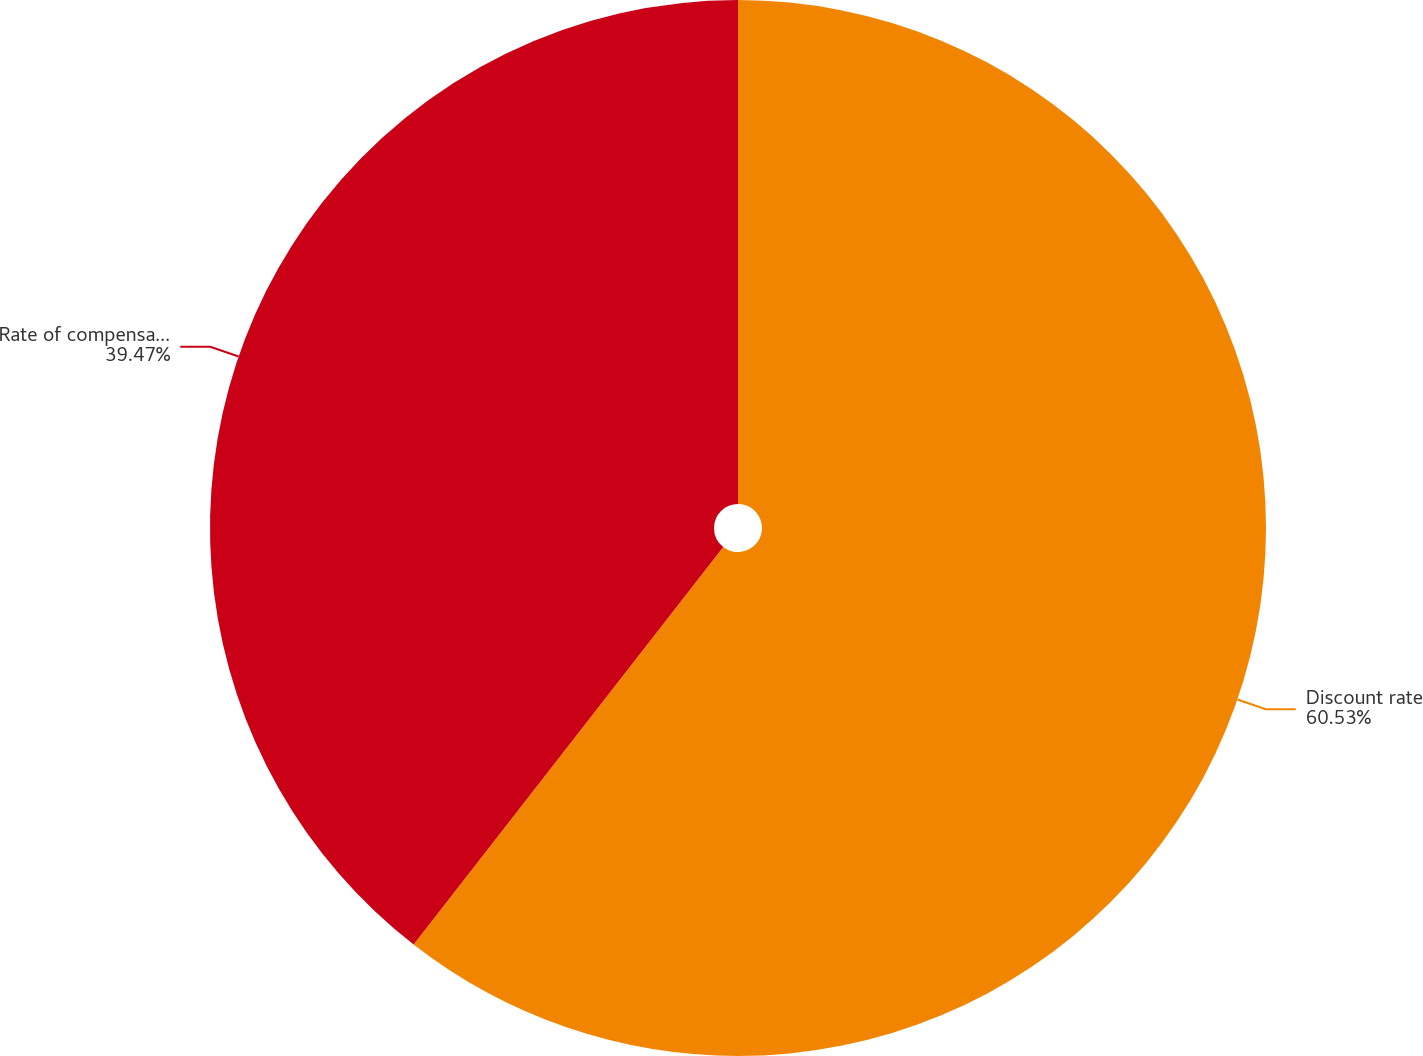Convert chart to OTSL. <chart><loc_0><loc_0><loc_500><loc_500><pie_chart><fcel>Discount rate<fcel>Rate of compensation increase<nl><fcel>60.53%<fcel>39.47%<nl></chart> 